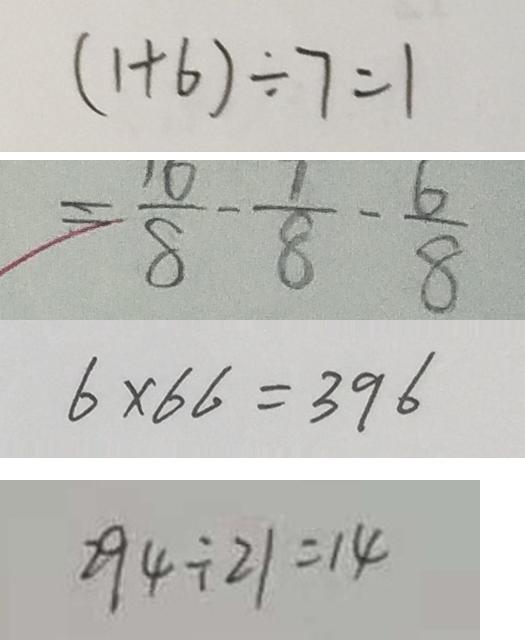<formula> <loc_0><loc_0><loc_500><loc_500>( 1 + 6 ) \div 7 = 1 
 = \frac { 1 0 } { 8 } - \frac { 1 } { 8 } - \frac { 6 } { 8 } 
 6 \times 6 6 = 3 9 6 
 2 9 4 \div 2 1 = 1 4</formula> 